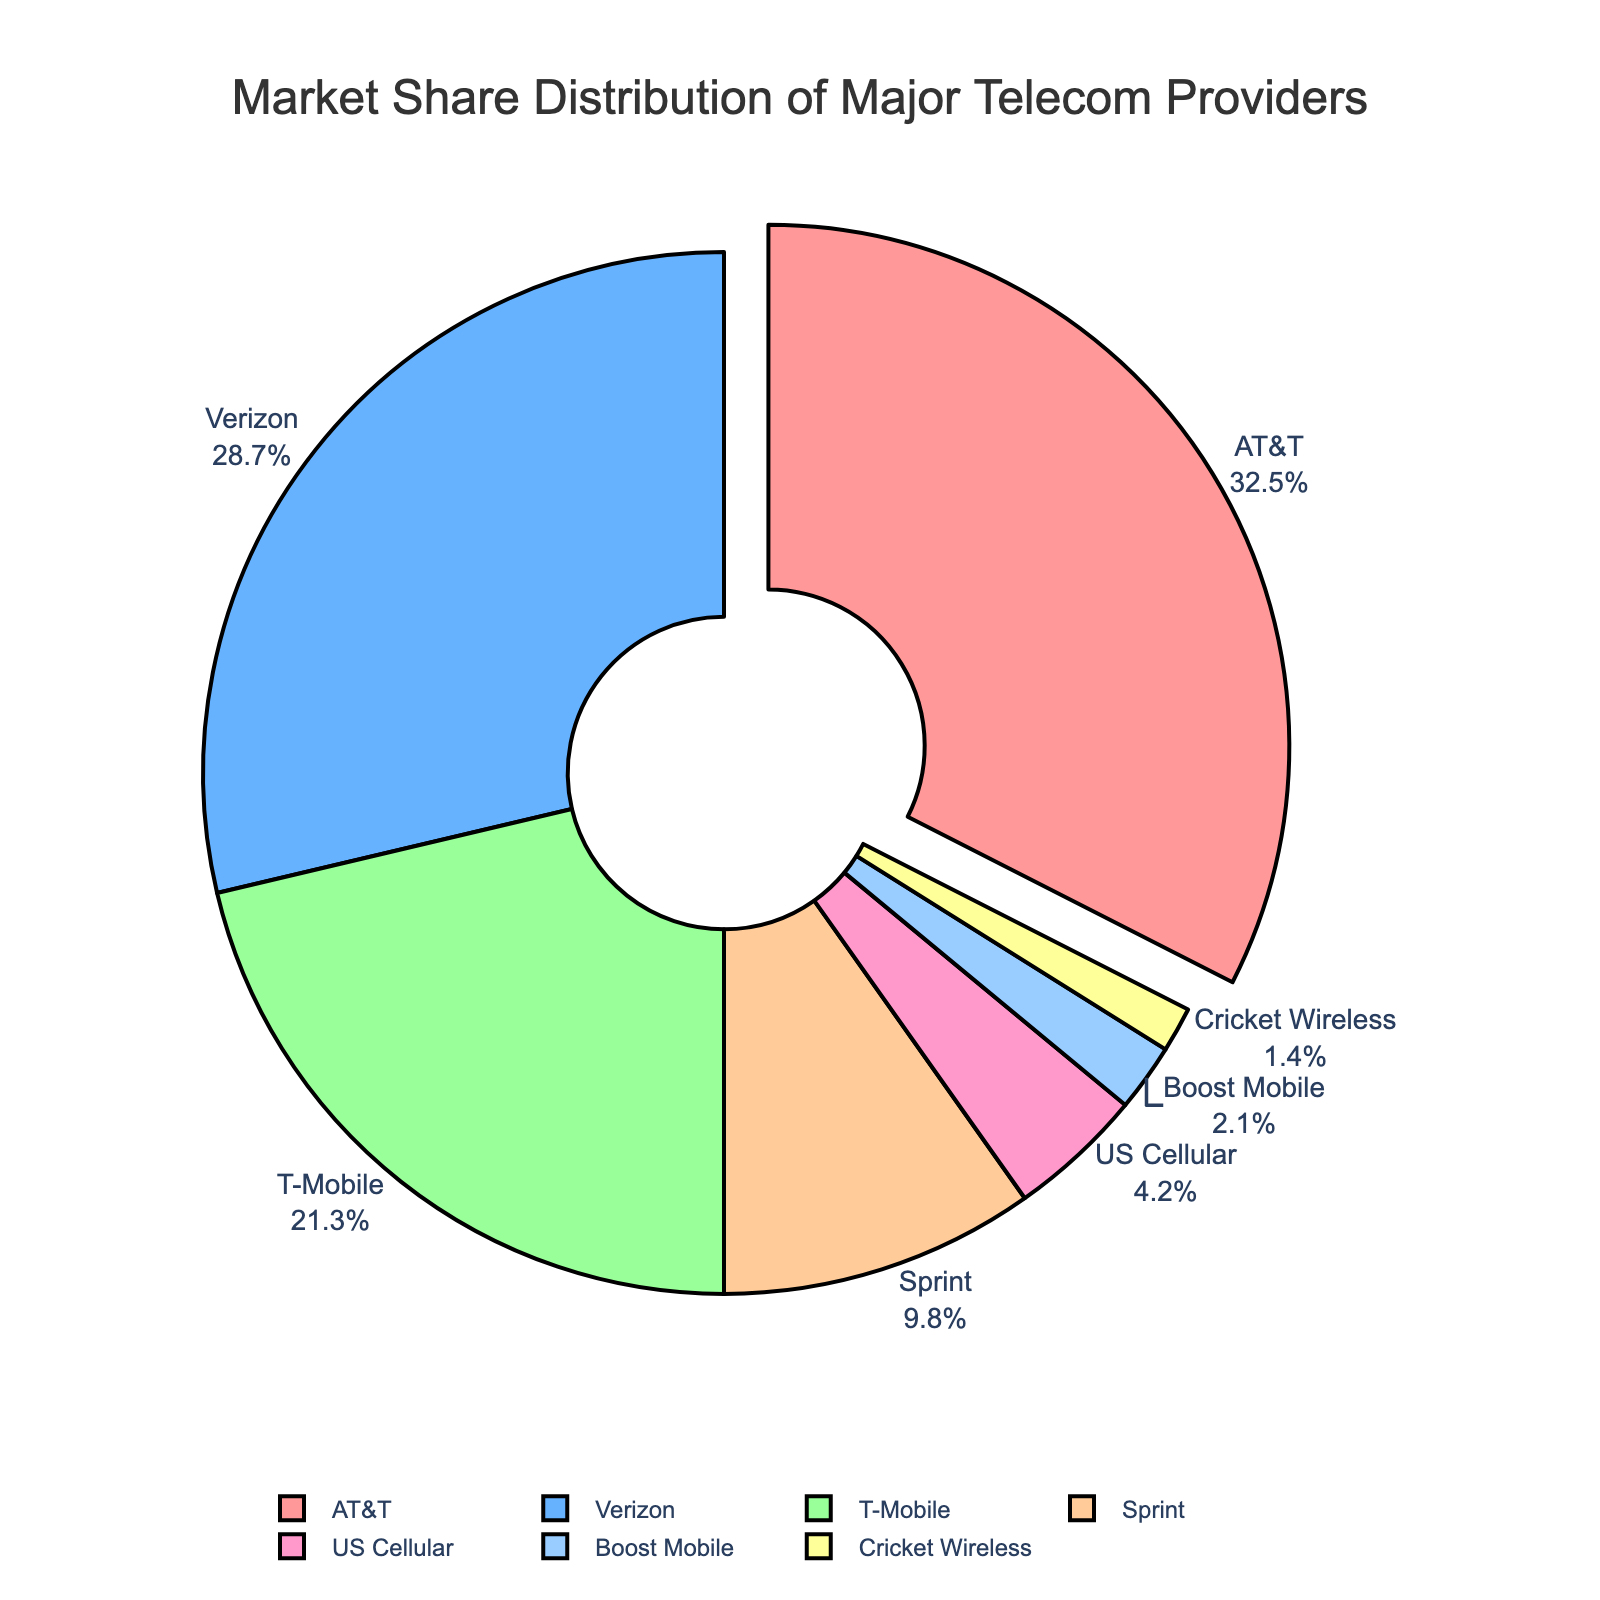What is the percentage of market share held by AT&T? The pie chart displays the market share of each company. According to the chart, AT&T holds 32.5% of the market share.
Answer: 32.5% Which company has the second largest market share? By examining the sizes of the pie slices, the company with the second largest segment after AT&T is Verizon. The chart shows Verizon holds 28.7% of the market share.
Answer: Verizon What is the combined market share of T-Mobile and Sprint? The pie chart shows T-Mobile has 21.3% and Sprint has 9.8%. To find the combined market share, add 21.3 and 9.8. Therefore, 21.3 + 9.8 = 31.1%.
Answer: 31.1% Which company has the smallest market share and what is its percentage? By observing the size of the slices, the smallest slice belongs to Cricket Wireless. According to the chart, Cricket Wireless holds 1.4% of the market share.
Answer: Cricket Wireless, 1.4% How much more market share does AT&T have compared to T-Mobile? AT&T has 32.5% while T-Mobile has 21.3%. Subtract T-Mobile's share from AT&T's share: 32.5 - 21.3 = 11.2%.
Answer: 11.2% What is the percentage difference between Verizon and Sprint's market shares? Verizon holds 28.7% and Sprint holds 9.8%. Subtract Sprint's share from Verizon’s share: 28.7 - 9.8 = 18.9%.
Answer: 18.9% Compare the market share of US Cellular to Boost Mobile. Is it greater or smaller? According to the chart, US Cellular holds 4.2% and Boost Mobile holds 2.1%. The number clearly shows US Cellular has a greater market share than Boost Mobile.
Answer: Greater What is the average market share among the listed companies? The total market share is the sum of the shares of all companies: 32.5 + 28.7 + 21.3 + 9.8 + 4.2 + 2.1 + 1.4 = 100. To find the average, divide 100 by the number of companies (7): 100 / 7 ≈ 14.3%.
Answer: 14.3% Which company’s segment color is green? Visual inspection of the chart reveals that the green slice corresponds to T-Mobile.
Answer: T-Mobile How does the size of the Verizon slice compare to the AT&T slice? The chart visually shows that the Verizon slice is smaller than the AT&T slice. Specifically, AT&T holds 32.5% and Verizon holds 28.7%, making AT&T's slice larger.
Answer: Smaller 